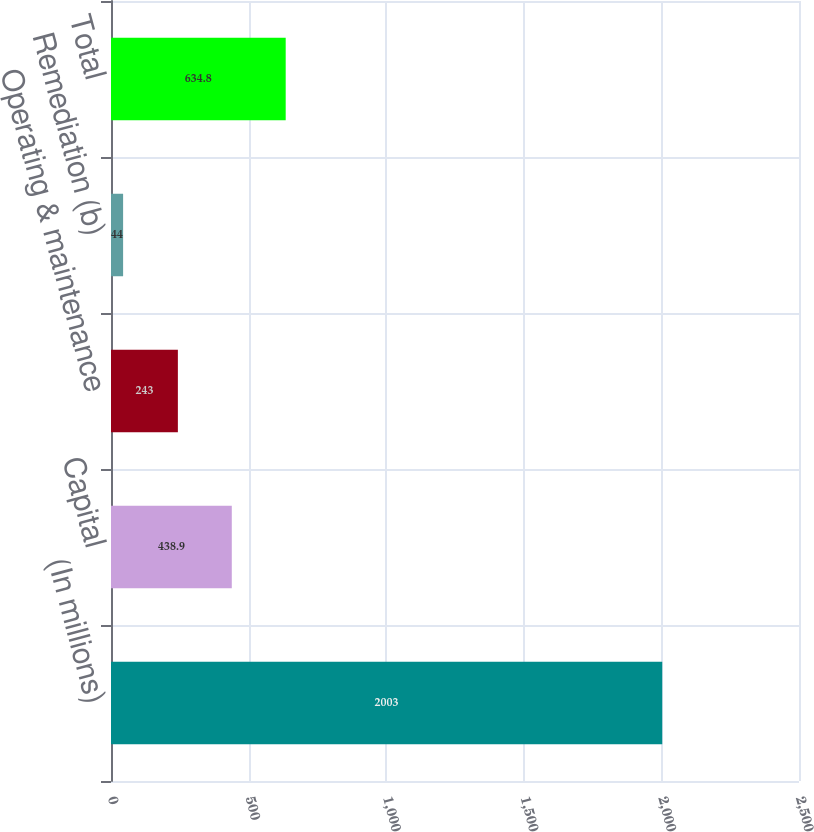Convert chart to OTSL. <chart><loc_0><loc_0><loc_500><loc_500><bar_chart><fcel>(In millions)<fcel>Capital<fcel>Operating & maintenance<fcel>Remediation (b)<fcel>Total<nl><fcel>2003<fcel>438.9<fcel>243<fcel>44<fcel>634.8<nl></chart> 